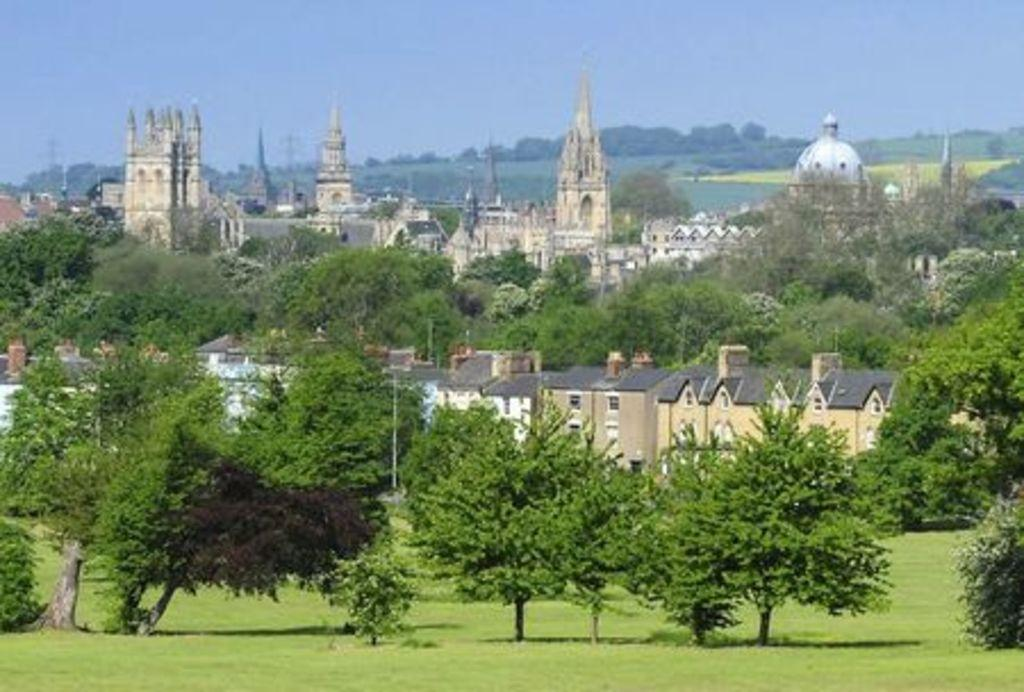What type of vegetation is present in the image? There are many trees, plants, and grass in the image. What structures can be seen in the image? There are buildings in the image. What is visible at the top of the image? The sky is visible at the top of the image. What object is located in the middle of the image? There is a pole in the middle of the image. How many deer are visible in the image? There are no deer present in the image. What type of animal can be seen interacting with the chickens in the image? There are no chickens or animals interacting with them in the image. 